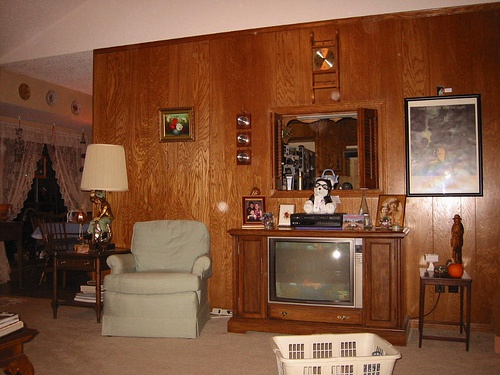Describe the objects in this image and their specific colors. I can see chair in brown, tan, and gray tones, tv in brown, gray, and black tones, chair in brown and black tones, dining table in brown, black, and gray tones, and clock in brown, maroon, red, and ivory tones in this image. 